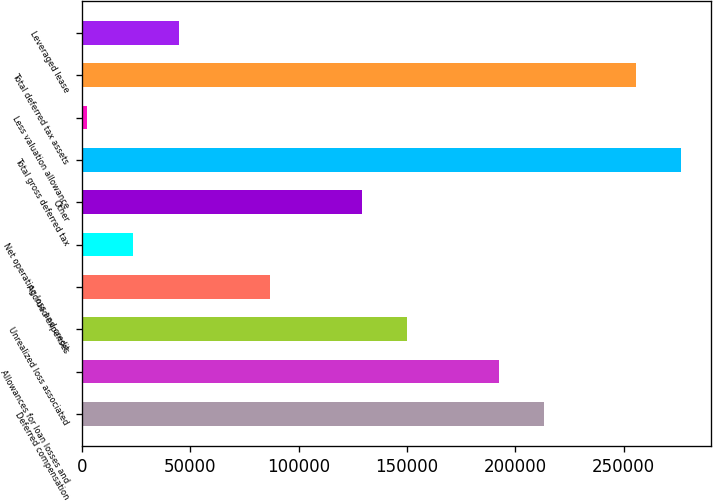<chart> <loc_0><loc_0><loc_500><loc_500><bar_chart><fcel>Deferred compensation<fcel>Allowances for loan losses and<fcel>Unrealized loss associated<fcel>Accrued expenses<fcel>Net operating loss and credit<fcel>Other<fcel>Total gross deferred tax<fcel>Less valuation allowance<fcel>Total deferred tax assets<fcel>Leveraged lease<nl><fcel>213407<fcel>192320<fcel>150146<fcel>86884.4<fcel>23623.1<fcel>129059<fcel>276668<fcel>2536<fcel>255581<fcel>44710.2<nl></chart> 